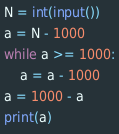<code> <loc_0><loc_0><loc_500><loc_500><_Python_>N = int(input())
a = N - 1000
while a >= 1000:
    a = a - 1000
a = 1000 - a
print(a)</code> 